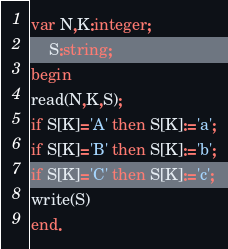<code> <loc_0><loc_0><loc_500><loc_500><_Pascal_>var N,K:integer;
    S:string;
begin
read(N,K,S);
if S[K]='A' then S[K]:='a';
if S[K]='B' then S[K]:='b';
if S[K]='C' then S[K]:='c';
write(S)
end.</code> 